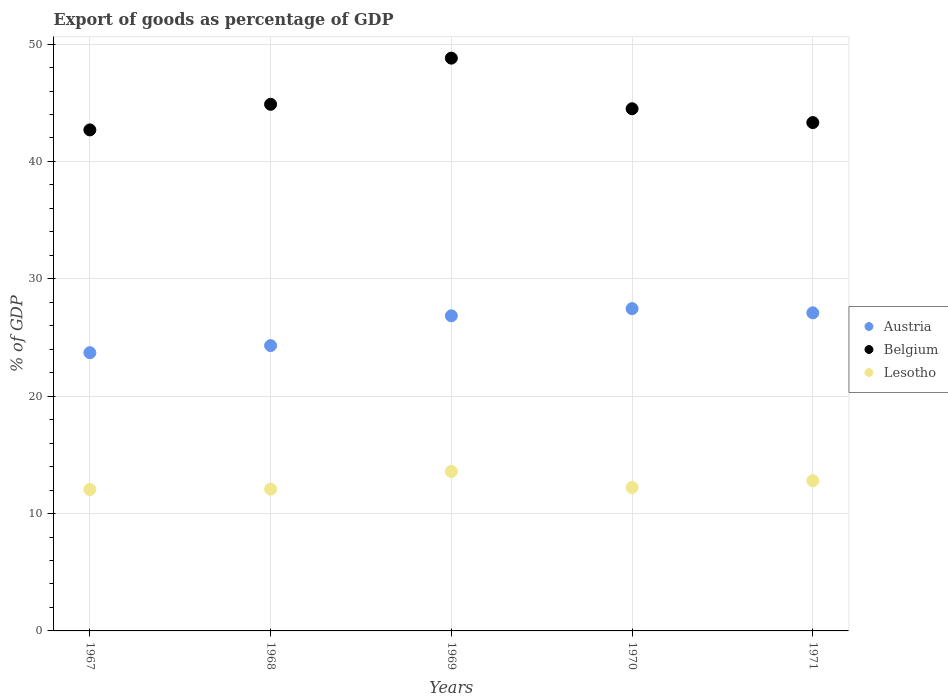How many different coloured dotlines are there?
Make the answer very short. 3. What is the export of goods as percentage of GDP in Austria in 1969?
Give a very brief answer. 26.85. Across all years, what is the maximum export of goods as percentage of GDP in Austria?
Provide a succinct answer. 27.46. Across all years, what is the minimum export of goods as percentage of GDP in Belgium?
Provide a succinct answer. 42.69. In which year was the export of goods as percentage of GDP in Austria maximum?
Your answer should be compact. 1970. In which year was the export of goods as percentage of GDP in Lesotho minimum?
Ensure brevity in your answer.  1967. What is the total export of goods as percentage of GDP in Austria in the graph?
Provide a short and direct response. 129.42. What is the difference between the export of goods as percentage of GDP in Austria in 1968 and that in 1970?
Your response must be concise. -3.15. What is the difference between the export of goods as percentage of GDP in Belgium in 1971 and the export of goods as percentage of GDP in Lesotho in 1970?
Give a very brief answer. 31.09. What is the average export of goods as percentage of GDP in Austria per year?
Provide a short and direct response. 25.88. In the year 1970, what is the difference between the export of goods as percentage of GDP in Austria and export of goods as percentage of GDP in Lesotho?
Give a very brief answer. 15.24. What is the ratio of the export of goods as percentage of GDP in Belgium in 1968 to that in 1971?
Make the answer very short. 1.04. Is the export of goods as percentage of GDP in Austria in 1967 less than that in 1968?
Offer a terse response. Yes. What is the difference between the highest and the second highest export of goods as percentage of GDP in Belgium?
Your response must be concise. 3.93. What is the difference between the highest and the lowest export of goods as percentage of GDP in Lesotho?
Offer a very short reply. 1.53. In how many years, is the export of goods as percentage of GDP in Belgium greater than the average export of goods as percentage of GDP in Belgium taken over all years?
Your answer should be very brief. 2. Does the export of goods as percentage of GDP in Austria monotonically increase over the years?
Keep it short and to the point. No. Is the export of goods as percentage of GDP in Austria strictly less than the export of goods as percentage of GDP in Lesotho over the years?
Ensure brevity in your answer.  No. How many years are there in the graph?
Provide a short and direct response. 5. How are the legend labels stacked?
Your answer should be compact. Vertical. What is the title of the graph?
Your answer should be compact. Export of goods as percentage of GDP. Does "Iraq" appear as one of the legend labels in the graph?
Give a very brief answer. No. What is the label or title of the X-axis?
Keep it short and to the point. Years. What is the label or title of the Y-axis?
Give a very brief answer. % of GDP. What is the % of GDP of Austria in 1967?
Your answer should be very brief. 23.7. What is the % of GDP in Belgium in 1967?
Give a very brief answer. 42.69. What is the % of GDP in Lesotho in 1967?
Your answer should be very brief. 12.05. What is the % of GDP of Austria in 1968?
Give a very brief answer. 24.31. What is the % of GDP in Belgium in 1968?
Make the answer very short. 44.87. What is the % of GDP of Lesotho in 1968?
Offer a very short reply. 12.08. What is the % of GDP in Austria in 1969?
Give a very brief answer. 26.85. What is the % of GDP in Belgium in 1969?
Give a very brief answer. 48.8. What is the % of GDP of Lesotho in 1969?
Your response must be concise. 13.58. What is the % of GDP of Austria in 1970?
Your answer should be very brief. 27.46. What is the % of GDP of Belgium in 1970?
Make the answer very short. 44.49. What is the % of GDP in Lesotho in 1970?
Keep it short and to the point. 12.22. What is the % of GDP in Austria in 1971?
Ensure brevity in your answer.  27.1. What is the % of GDP in Belgium in 1971?
Ensure brevity in your answer.  43.31. What is the % of GDP in Lesotho in 1971?
Make the answer very short. 12.8. Across all years, what is the maximum % of GDP in Austria?
Keep it short and to the point. 27.46. Across all years, what is the maximum % of GDP of Belgium?
Provide a short and direct response. 48.8. Across all years, what is the maximum % of GDP of Lesotho?
Offer a terse response. 13.58. Across all years, what is the minimum % of GDP of Austria?
Your answer should be compact. 23.7. Across all years, what is the minimum % of GDP in Belgium?
Keep it short and to the point. 42.69. Across all years, what is the minimum % of GDP in Lesotho?
Make the answer very short. 12.05. What is the total % of GDP of Austria in the graph?
Your response must be concise. 129.42. What is the total % of GDP in Belgium in the graph?
Provide a short and direct response. 224.15. What is the total % of GDP in Lesotho in the graph?
Give a very brief answer. 62.72. What is the difference between the % of GDP in Austria in 1967 and that in 1968?
Provide a short and direct response. -0.6. What is the difference between the % of GDP in Belgium in 1967 and that in 1968?
Offer a very short reply. -2.18. What is the difference between the % of GDP in Lesotho in 1967 and that in 1968?
Your answer should be compact. -0.03. What is the difference between the % of GDP of Austria in 1967 and that in 1969?
Offer a very short reply. -3.14. What is the difference between the % of GDP of Belgium in 1967 and that in 1969?
Ensure brevity in your answer.  -6.11. What is the difference between the % of GDP in Lesotho in 1967 and that in 1969?
Your answer should be very brief. -1.53. What is the difference between the % of GDP in Austria in 1967 and that in 1970?
Your response must be concise. -3.75. What is the difference between the % of GDP of Belgium in 1967 and that in 1970?
Your answer should be very brief. -1.8. What is the difference between the % of GDP of Lesotho in 1967 and that in 1970?
Your answer should be compact. -0.17. What is the difference between the % of GDP in Austria in 1967 and that in 1971?
Provide a short and direct response. -3.4. What is the difference between the % of GDP of Belgium in 1967 and that in 1971?
Provide a short and direct response. -0.62. What is the difference between the % of GDP of Lesotho in 1967 and that in 1971?
Make the answer very short. -0.75. What is the difference between the % of GDP in Austria in 1968 and that in 1969?
Ensure brevity in your answer.  -2.54. What is the difference between the % of GDP of Belgium in 1968 and that in 1969?
Provide a short and direct response. -3.93. What is the difference between the % of GDP in Lesotho in 1968 and that in 1969?
Your response must be concise. -1.51. What is the difference between the % of GDP of Austria in 1968 and that in 1970?
Keep it short and to the point. -3.15. What is the difference between the % of GDP in Belgium in 1968 and that in 1970?
Offer a terse response. 0.38. What is the difference between the % of GDP of Lesotho in 1968 and that in 1970?
Your answer should be very brief. -0.14. What is the difference between the % of GDP of Austria in 1968 and that in 1971?
Give a very brief answer. -2.79. What is the difference between the % of GDP of Belgium in 1968 and that in 1971?
Give a very brief answer. 1.56. What is the difference between the % of GDP of Lesotho in 1968 and that in 1971?
Keep it short and to the point. -0.72. What is the difference between the % of GDP of Austria in 1969 and that in 1970?
Provide a short and direct response. -0.61. What is the difference between the % of GDP in Belgium in 1969 and that in 1970?
Make the answer very short. 4.31. What is the difference between the % of GDP in Lesotho in 1969 and that in 1970?
Ensure brevity in your answer.  1.36. What is the difference between the % of GDP of Austria in 1969 and that in 1971?
Your answer should be very brief. -0.25. What is the difference between the % of GDP of Belgium in 1969 and that in 1971?
Provide a short and direct response. 5.49. What is the difference between the % of GDP in Lesotho in 1969 and that in 1971?
Your response must be concise. 0.79. What is the difference between the % of GDP of Austria in 1970 and that in 1971?
Your answer should be compact. 0.36. What is the difference between the % of GDP of Belgium in 1970 and that in 1971?
Provide a succinct answer. 1.18. What is the difference between the % of GDP in Lesotho in 1970 and that in 1971?
Provide a succinct answer. -0.58. What is the difference between the % of GDP of Austria in 1967 and the % of GDP of Belgium in 1968?
Your response must be concise. -21.16. What is the difference between the % of GDP of Austria in 1967 and the % of GDP of Lesotho in 1968?
Offer a terse response. 11.63. What is the difference between the % of GDP of Belgium in 1967 and the % of GDP of Lesotho in 1968?
Offer a very short reply. 30.61. What is the difference between the % of GDP of Austria in 1967 and the % of GDP of Belgium in 1969?
Your response must be concise. -25.1. What is the difference between the % of GDP of Austria in 1967 and the % of GDP of Lesotho in 1969?
Your response must be concise. 10.12. What is the difference between the % of GDP of Belgium in 1967 and the % of GDP of Lesotho in 1969?
Ensure brevity in your answer.  29.1. What is the difference between the % of GDP of Austria in 1967 and the % of GDP of Belgium in 1970?
Provide a succinct answer. -20.78. What is the difference between the % of GDP of Austria in 1967 and the % of GDP of Lesotho in 1970?
Give a very brief answer. 11.48. What is the difference between the % of GDP in Belgium in 1967 and the % of GDP in Lesotho in 1970?
Your answer should be very brief. 30.47. What is the difference between the % of GDP of Austria in 1967 and the % of GDP of Belgium in 1971?
Offer a very short reply. -19.61. What is the difference between the % of GDP in Austria in 1967 and the % of GDP in Lesotho in 1971?
Your answer should be compact. 10.91. What is the difference between the % of GDP in Belgium in 1967 and the % of GDP in Lesotho in 1971?
Ensure brevity in your answer.  29.89. What is the difference between the % of GDP of Austria in 1968 and the % of GDP of Belgium in 1969?
Make the answer very short. -24.49. What is the difference between the % of GDP of Austria in 1968 and the % of GDP of Lesotho in 1969?
Your answer should be very brief. 10.73. What is the difference between the % of GDP of Belgium in 1968 and the % of GDP of Lesotho in 1969?
Provide a succinct answer. 31.28. What is the difference between the % of GDP of Austria in 1968 and the % of GDP of Belgium in 1970?
Your response must be concise. -20.18. What is the difference between the % of GDP in Austria in 1968 and the % of GDP in Lesotho in 1970?
Give a very brief answer. 12.09. What is the difference between the % of GDP in Belgium in 1968 and the % of GDP in Lesotho in 1970?
Give a very brief answer. 32.65. What is the difference between the % of GDP in Austria in 1968 and the % of GDP in Belgium in 1971?
Your response must be concise. -19. What is the difference between the % of GDP in Austria in 1968 and the % of GDP in Lesotho in 1971?
Make the answer very short. 11.51. What is the difference between the % of GDP of Belgium in 1968 and the % of GDP of Lesotho in 1971?
Offer a very short reply. 32.07. What is the difference between the % of GDP in Austria in 1969 and the % of GDP in Belgium in 1970?
Ensure brevity in your answer.  -17.64. What is the difference between the % of GDP in Austria in 1969 and the % of GDP in Lesotho in 1970?
Keep it short and to the point. 14.63. What is the difference between the % of GDP of Belgium in 1969 and the % of GDP of Lesotho in 1970?
Your answer should be compact. 36.58. What is the difference between the % of GDP in Austria in 1969 and the % of GDP in Belgium in 1971?
Your answer should be very brief. -16.46. What is the difference between the % of GDP in Austria in 1969 and the % of GDP in Lesotho in 1971?
Give a very brief answer. 14.05. What is the difference between the % of GDP in Belgium in 1969 and the % of GDP in Lesotho in 1971?
Keep it short and to the point. 36. What is the difference between the % of GDP in Austria in 1970 and the % of GDP in Belgium in 1971?
Your answer should be compact. -15.85. What is the difference between the % of GDP in Austria in 1970 and the % of GDP in Lesotho in 1971?
Give a very brief answer. 14.66. What is the difference between the % of GDP of Belgium in 1970 and the % of GDP of Lesotho in 1971?
Your answer should be very brief. 31.69. What is the average % of GDP in Austria per year?
Your response must be concise. 25.88. What is the average % of GDP of Belgium per year?
Offer a terse response. 44.83. What is the average % of GDP in Lesotho per year?
Your response must be concise. 12.54. In the year 1967, what is the difference between the % of GDP in Austria and % of GDP in Belgium?
Keep it short and to the point. -18.98. In the year 1967, what is the difference between the % of GDP in Austria and % of GDP in Lesotho?
Your answer should be very brief. 11.66. In the year 1967, what is the difference between the % of GDP in Belgium and % of GDP in Lesotho?
Keep it short and to the point. 30.64. In the year 1968, what is the difference between the % of GDP of Austria and % of GDP of Belgium?
Your answer should be compact. -20.56. In the year 1968, what is the difference between the % of GDP in Austria and % of GDP in Lesotho?
Your answer should be compact. 12.23. In the year 1968, what is the difference between the % of GDP of Belgium and % of GDP of Lesotho?
Keep it short and to the point. 32.79. In the year 1969, what is the difference between the % of GDP of Austria and % of GDP of Belgium?
Give a very brief answer. -21.95. In the year 1969, what is the difference between the % of GDP in Austria and % of GDP in Lesotho?
Make the answer very short. 13.27. In the year 1969, what is the difference between the % of GDP in Belgium and % of GDP in Lesotho?
Your answer should be compact. 35.22. In the year 1970, what is the difference between the % of GDP of Austria and % of GDP of Belgium?
Your answer should be very brief. -17.03. In the year 1970, what is the difference between the % of GDP in Austria and % of GDP in Lesotho?
Keep it short and to the point. 15.24. In the year 1970, what is the difference between the % of GDP of Belgium and % of GDP of Lesotho?
Ensure brevity in your answer.  32.27. In the year 1971, what is the difference between the % of GDP of Austria and % of GDP of Belgium?
Your response must be concise. -16.21. In the year 1971, what is the difference between the % of GDP in Austria and % of GDP in Lesotho?
Your answer should be very brief. 14.3. In the year 1971, what is the difference between the % of GDP in Belgium and % of GDP in Lesotho?
Your response must be concise. 30.51. What is the ratio of the % of GDP in Austria in 1967 to that in 1968?
Your answer should be very brief. 0.98. What is the ratio of the % of GDP in Belgium in 1967 to that in 1968?
Your response must be concise. 0.95. What is the ratio of the % of GDP in Austria in 1967 to that in 1969?
Keep it short and to the point. 0.88. What is the ratio of the % of GDP in Belgium in 1967 to that in 1969?
Provide a short and direct response. 0.87. What is the ratio of the % of GDP in Lesotho in 1967 to that in 1969?
Your response must be concise. 0.89. What is the ratio of the % of GDP in Austria in 1967 to that in 1970?
Offer a very short reply. 0.86. What is the ratio of the % of GDP of Belgium in 1967 to that in 1970?
Give a very brief answer. 0.96. What is the ratio of the % of GDP in Lesotho in 1967 to that in 1970?
Offer a very short reply. 0.99. What is the ratio of the % of GDP of Austria in 1967 to that in 1971?
Your answer should be compact. 0.87. What is the ratio of the % of GDP in Belgium in 1967 to that in 1971?
Your response must be concise. 0.99. What is the ratio of the % of GDP of Lesotho in 1967 to that in 1971?
Provide a short and direct response. 0.94. What is the ratio of the % of GDP of Austria in 1968 to that in 1969?
Your answer should be compact. 0.91. What is the ratio of the % of GDP in Belgium in 1968 to that in 1969?
Your response must be concise. 0.92. What is the ratio of the % of GDP of Lesotho in 1968 to that in 1969?
Your answer should be very brief. 0.89. What is the ratio of the % of GDP in Austria in 1968 to that in 1970?
Ensure brevity in your answer.  0.89. What is the ratio of the % of GDP in Belgium in 1968 to that in 1970?
Make the answer very short. 1.01. What is the ratio of the % of GDP in Austria in 1968 to that in 1971?
Your answer should be very brief. 0.9. What is the ratio of the % of GDP in Belgium in 1968 to that in 1971?
Ensure brevity in your answer.  1.04. What is the ratio of the % of GDP in Lesotho in 1968 to that in 1971?
Give a very brief answer. 0.94. What is the ratio of the % of GDP of Austria in 1969 to that in 1970?
Provide a succinct answer. 0.98. What is the ratio of the % of GDP in Belgium in 1969 to that in 1970?
Ensure brevity in your answer.  1.1. What is the ratio of the % of GDP in Lesotho in 1969 to that in 1970?
Keep it short and to the point. 1.11. What is the ratio of the % of GDP in Austria in 1969 to that in 1971?
Offer a terse response. 0.99. What is the ratio of the % of GDP in Belgium in 1969 to that in 1971?
Your response must be concise. 1.13. What is the ratio of the % of GDP of Lesotho in 1969 to that in 1971?
Give a very brief answer. 1.06. What is the ratio of the % of GDP of Austria in 1970 to that in 1971?
Offer a very short reply. 1.01. What is the ratio of the % of GDP in Belgium in 1970 to that in 1971?
Your answer should be very brief. 1.03. What is the ratio of the % of GDP in Lesotho in 1970 to that in 1971?
Your response must be concise. 0.95. What is the difference between the highest and the second highest % of GDP of Austria?
Provide a short and direct response. 0.36. What is the difference between the highest and the second highest % of GDP in Belgium?
Provide a succinct answer. 3.93. What is the difference between the highest and the second highest % of GDP in Lesotho?
Make the answer very short. 0.79. What is the difference between the highest and the lowest % of GDP of Austria?
Offer a terse response. 3.75. What is the difference between the highest and the lowest % of GDP of Belgium?
Your response must be concise. 6.11. What is the difference between the highest and the lowest % of GDP of Lesotho?
Provide a short and direct response. 1.53. 